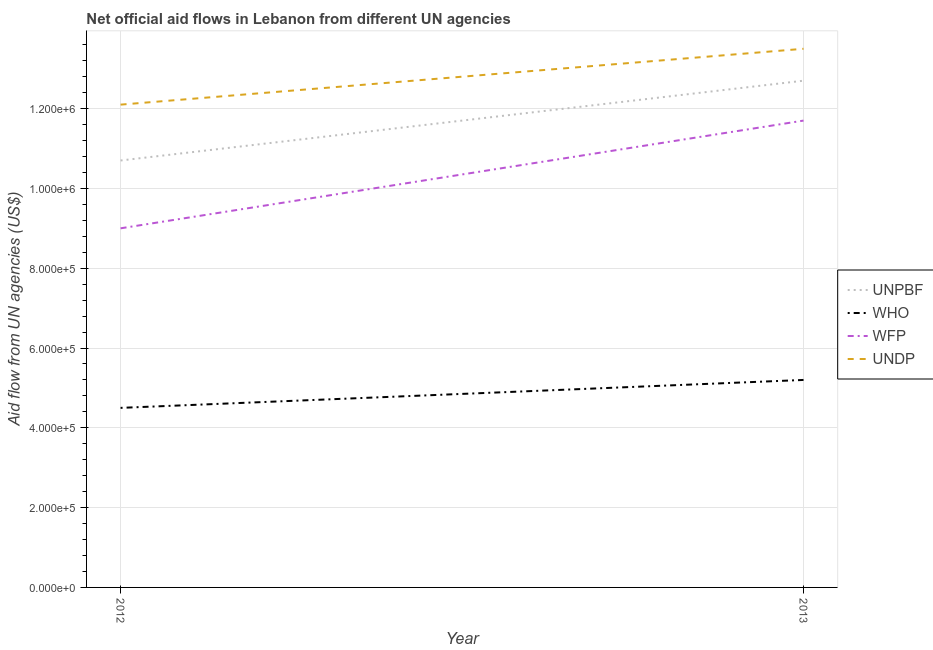Is the number of lines equal to the number of legend labels?
Provide a succinct answer. Yes. What is the amount of aid given by undp in 2013?
Offer a very short reply. 1.35e+06. Across all years, what is the maximum amount of aid given by wfp?
Ensure brevity in your answer.  1.17e+06. Across all years, what is the minimum amount of aid given by unpbf?
Make the answer very short. 1.07e+06. In which year was the amount of aid given by wfp minimum?
Make the answer very short. 2012. What is the total amount of aid given by who in the graph?
Ensure brevity in your answer.  9.70e+05. What is the difference between the amount of aid given by unpbf in 2012 and that in 2013?
Provide a succinct answer. -2.00e+05. What is the difference between the amount of aid given by who in 2012 and the amount of aid given by wfp in 2013?
Your answer should be compact. -7.20e+05. What is the average amount of aid given by undp per year?
Offer a very short reply. 1.28e+06. In the year 2013, what is the difference between the amount of aid given by unpbf and amount of aid given by undp?
Your answer should be very brief. -8.00e+04. What is the ratio of the amount of aid given by unpbf in 2012 to that in 2013?
Your response must be concise. 0.84. Is the amount of aid given by wfp in 2012 less than that in 2013?
Give a very brief answer. Yes. In how many years, is the amount of aid given by wfp greater than the average amount of aid given by wfp taken over all years?
Offer a very short reply. 1. Is it the case that in every year, the sum of the amount of aid given by wfp and amount of aid given by undp is greater than the sum of amount of aid given by unpbf and amount of aid given by who?
Ensure brevity in your answer.  No. Is the amount of aid given by who strictly greater than the amount of aid given by unpbf over the years?
Provide a succinct answer. No. Is the amount of aid given by unpbf strictly less than the amount of aid given by undp over the years?
Give a very brief answer. Yes. How many lines are there?
Your response must be concise. 4. How many years are there in the graph?
Offer a very short reply. 2. Does the graph contain any zero values?
Your answer should be very brief. No. Does the graph contain grids?
Ensure brevity in your answer.  Yes. Where does the legend appear in the graph?
Provide a short and direct response. Center right. How many legend labels are there?
Offer a terse response. 4. How are the legend labels stacked?
Provide a short and direct response. Vertical. What is the title of the graph?
Your response must be concise. Net official aid flows in Lebanon from different UN agencies. Does "Tertiary education" appear as one of the legend labels in the graph?
Your answer should be very brief. No. What is the label or title of the Y-axis?
Your response must be concise. Aid flow from UN agencies (US$). What is the Aid flow from UN agencies (US$) of UNPBF in 2012?
Your answer should be very brief. 1.07e+06. What is the Aid flow from UN agencies (US$) of WHO in 2012?
Your answer should be very brief. 4.50e+05. What is the Aid flow from UN agencies (US$) of UNDP in 2012?
Offer a very short reply. 1.21e+06. What is the Aid flow from UN agencies (US$) of UNPBF in 2013?
Keep it short and to the point. 1.27e+06. What is the Aid flow from UN agencies (US$) in WHO in 2013?
Your answer should be compact. 5.20e+05. What is the Aid flow from UN agencies (US$) in WFP in 2013?
Provide a succinct answer. 1.17e+06. What is the Aid flow from UN agencies (US$) of UNDP in 2013?
Make the answer very short. 1.35e+06. Across all years, what is the maximum Aid flow from UN agencies (US$) in UNPBF?
Ensure brevity in your answer.  1.27e+06. Across all years, what is the maximum Aid flow from UN agencies (US$) in WHO?
Offer a terse response. 5.20e+05. Across all years, what is the maximum Aid flow from UN agencies (US$) in WFP?
Give a very brief answer. 1.17e+06. Across all years, what is the maximum Aid flow from UN agencies (US$) in UNDP?
Your response must be concise. 1.35e+06. Across all years, what is the minimum Aid flow from UN agencies (US$) of UNPBF?
Offer a very short reply. 1.07e+06. Across all years, what is the minimum Aid flow from UN agencies (US$) in UNDP?
Provide a succinct answer. 1.21e+06. What is the total Aid flow from UN agencies (US$) of UNPBF in the graph?
Your answer should be very brief. 2.34e+06. What is the total Aid flow from UN agencies (US$) of WHO in the graph?
Your answer should be very brief. 9.70e+05. What is the total Aid flow from UN agencies (US$) in WFP in the graph?
Make the answer very short. 2.07e+06. What is the total Aid flow from UN agencies (US$) in UNDP in the graph?
Keep it short and to the point. 2.56e+06. What is the difference between the Aid flow from UN agencies (US$) of WHO in 2012 and that in 2013?
Provide a succinct answer. -7.00e+04. What is the difference between the Aid flow from UN agencies (US$) of WFP in 2012 and that in 2013?
Make the answer very short. -2.70e+05. What is the difference between the Aid flow from UN agencies (US$) of UNPBF in 2012 and the Aid flow from UN agencies (US$) of WHO in 2013?
Your response must be concise. 5.50e+05. What is the difference between the Aid flow from UN agencies (US$) of UNPBF in 2012 and the Aid flow from UN agencies (US$) of UNDP in 2013?
Give a very brief answer. -2.80e+05. What is the difference between the Aid flow from UN agencies (US$) of WHO in 2012 and the Aid flow from UN agencies (US$) of WFP in 2013?
Give a very brief answer. -7.20e+05. What is the difference between the Aid flow from UN agencies (US$) in WHO in 2012 and the Aid flow from UN agencies (US$) in UNDP in 2013?
Your answer should be compact. -9.00e+05. What is the difference between the Aid flow from UN agencies (US$) of WFP in 2012 and the Aid flow from UN agencies (US$) of UNDP in 2013?
Ensure brevity in your answer.  -4.50e+05. What is the average Aid flow from UN agencies (US$) of UNPBF per year?
Your answer should be compact. 1.17e+06. What is the average Aid flow from UN agencies (US$) in WHO per year?
Offer a terse response. 4.85e+05. What is the average Aid flow from UN agencies (US$) of WFP per year?
Your response must be concise. 1.04e+06. What is the average Aid flow from UN agencies (US$) in UNDP per year?
Provide a succinct answer. 1.28e+06. In the year 2012, what is the difference between the Aid flow from UN agencies (US$) of UNPBF and Aid flow from UN agencies (US$) of WHO?
Provide a short and direct response. 6.20e+05. In the year 2012, what is the difference between the Aid flow from UN agencies (US$) in UNPBF and Aid flow from UN agencies (US$) in UNDP?
Make the answer very short. -1.40e+05. In the year 2012, what is the difference between the Aid flow from UN agencies (US$) in WHO and Aid flow from UN agencies (US$) in WFP?
Keep it short and to the point. -4.50e+05. In the year 2012, what is the difference between the Aid flow from UN agencies (US$) in WHO and Aid flow from UN agencies (US$) in UNDP?
Offer a very short reply. -7.60e+05. In the year 2012, what is the difference between the Aid flow from UN agencies (US$) in WFP and Aid flow from UN agencies (US$) in UNDP?
Ensure brevity in your answer.  -3.10e+05. In the year 2013, what is the difference between the Aid flow from UN agencies (US$) of UNPBF and Aid flow from UN agencies (US$) of WHO?
Offer a very short reply. 7.50e+05. In the year 2013, what is the difference between the Aid flow from UN agencies (US$) of WHO and Aid flow from UN agencies (US$) of WFP?
Give a very brief answer. -6.50e+05. In the year 2013, what is the difference between the Aid flow from UN agencies (US$) of WHO and Aid flow from UN agencies (US$) of UNDP?
Give a very brief answer. -8.30e+05. In the year 2013, what is the difference between the Aid flow from UN agencies (US$) in WFP and Aid flow from UN agencies (US$) in UNDP?
Your answer should be very brief. -1.80e+05. What is the ratio of the Aid flow from UN agencies (US$) of UNPBF in 2012 to that in 2013?
Provide a succinct answer. 0.84. What is the ratio of the Aid flow from UN agencies (US$) in WHO in 2012 to that in 2013?
Provide a short and direct response. 0.87. What is the ratio of the Aid flow from UN agencies (US$) of WFP in 2012 to that in 2013?
Offer a terse response. 0.77. What is the ratio of the Aid flow from UN agencies (US$) of UNDP in 2012 to that in 2013?
Keep it short and to the point. 0.9. What is the difference between the highest and the second highest Aid flow from UN agencies (US$) of UNPBF?
Your answer should be compact. 2.00e+05. What is the difference between the highest and the second highest Aid flow from UN agencies (US$) in WHO?
Provide a succinct answer. 7.00e+04. What is the difference between the highest and the second highest Aid flow from UN agencies (US$) in UNDP?
Offer a terse response. 1.40e+05. What is the difference between the highest and the lowest Aid flow from UN agencies (US$) of UNPBF?
Ensure brevity in your answer.  2.00e+05. 